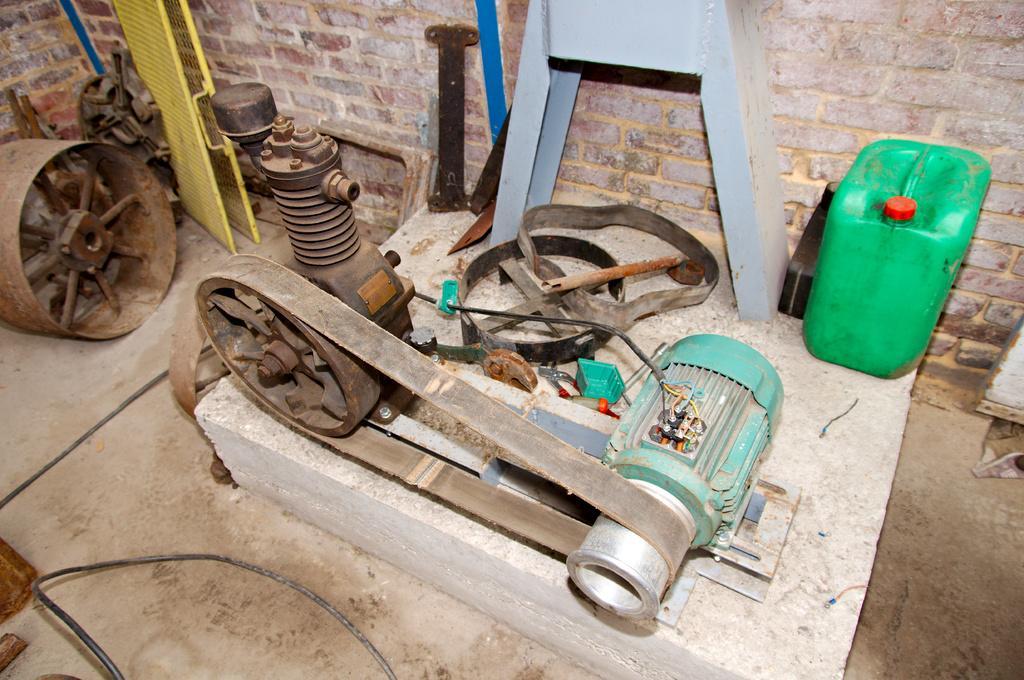How would you summarize this image in a sentence or two? In this picture there is a motor which has a belt attached to it and there are few other objects beside it. 